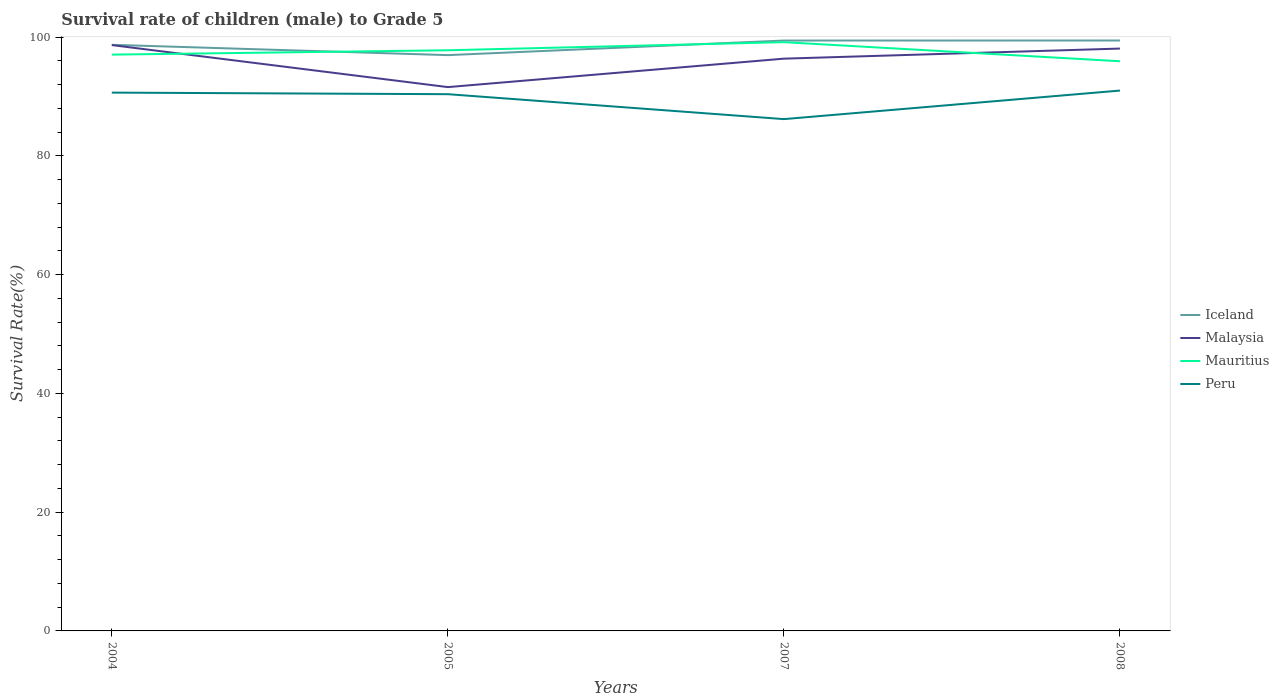How many different coloured lines are there?
Offer a very short reply. 4. Does the line corresponding to Peru intersect with the line corresponding to Mauritius?
Provide a succinct answer. No. Is the number of lines equal to the number of legend labels?
Keep it short and to the point. Yes. Across all years, what is the maximum survival rate of male children to grade 5 in Malaysia?
Your answer should be very brief. 91.58. In which year was the survival rate of male children to grade 5 in Mauritius maximum?
Ensure brevity in your answer.  2008. What is the total survival rate of male children to grade 5 in Peru in the graph?
Ensure brevity in your answer.  4.2. What is the difference between the highest and the second highest survival rate of male children to grade 5 in Malaysia?
Keep it short and to the point. 7.08. What is the difference between the highest and the lowest survival rate of male children to grade 5 in Mauritius?
Provide a short and direct response. 2. Is the survival rate of male children to grade 5 in Mauritius strictly greater than the survival rate of male children to grade 5 in Peru over the years?
Give a very brief answer. No. How many years are there in the graph?
Offer a terse response. 4. What is the difference between two consecutive major ticks on the Y-axis?
Give a very brief answer. 20. Are the values on the major ticks of Y-axis written in scientific E-notation?
Your answer should be very brief. No. Where does the legend appear in the graph?
Provide a short and direct response. Center right. How many legend labels are there?
Give a very brief answer. 4. What is the title of the graph?
Keep it short and to the point. Survival rate of children (male) to Grade 5. Does "Sri Lanka" appear as one of the legend labels in the graph?
Your response must be concise. No. What is the label or title of the Y-axis?
Your response must be concise. Survival Rate(%). What is the Survival Rate(%) of Iceland in 2004?
Offer a very short reply. 98.7. What is the Survival Rate(%) of Malaysia in 2004?
Ensure brevity in your answer.  98.66. What is the Survival Rate(%) of Mauritius in 2004?
Keep it short and to the point. 97.05. What is the Survival Rate(%) of Peru in 2004?
Provide a succinct answer. 90.65. What is the Survival Rate(%) of Iceland in 2005?
Ensure brevity in your answer.  96.97. What is the Survival Rate(%) in Malaysia in 2005?
Give a very brief answer. 91.58. What is the Survival Rate(%) of Mauritius in 2005?
Provide a succinct answer. 97.78. What is the Survival Rate(%) of Peru in 2005?
Your response must be concise. 90.39. What is the Survival Rate(%) in Iceland in 2007?
Your response must be concise. 99.42. What is the Survival Rate(%) of Malaysia in 2007?
Give a very brief answer. 96.37. What is the Survival Rate(%) in Mauritius in 2007?
Offer a very short reply. 99.15. What is the Survival Rate(%) in Peru in 2007?
Make the answer very short. 86.19. What is the Survival Rate(%) of Iceland in 2008?
Offer a very short reply. 99.43. What is the Survival Rate(%) of Malaysia in 2008?
Offer a terse response. 98.07. What is the Survival Rate(%) of Mauritius in 2008?
Offer a very short reply. 95.94. What is the Survival Rate(%) of Peru in 2008?
Your answer should be very brief. 91. Across all years, what is the maximum Survival Rate(%) in Iceland?
Make the answer very short. 99.43. Across all years, what is the maximum Survival Rate(%) in Malaysia?
Your answer should be very brief. 98.66. Across all years, what is the maximum Survival Rate(%) of Mauritius?
Keep it short and to the point. 99.15. Across all years, what is the maximum Survival Rate(%) of Peru?
Offer a terse response. 91. Across all years, what is the minimum Survival Rate(%) of Iceland?
Make the answer very short. 96.97. Across all years, what is the minimum Survival Rate(%) of Malaysia?
Ensure brevity in your answer.  91.58. Across all years, what is the minimum Survival Rate(%) in Mauritius?
Keep it short and to the point. 95.94. Across all years, what is the minimum Survival Rate(%) in Peru?
Keep it short and to the point. 86.19. What is the total Survival Rate(%) in Iceland in the graph?
Keep it short and to the point. 394.52. What is the total Survival Rate(%) of Malaysia in the graph?
Your answer should be compact. 384.68. What is the total Survival Rate(%) of Mauritius in the graph?
Give a very brief answer. 389.92. What is the total Survival Rate(%) in Peru in the graph?
Your answer should be compact. 358.23. What is the difference between the Survival Rate(%) of Iceland in 2004 and that in 2005?
Offer a terse response. 1.73. What is the difference between the Survival Rate(%) of Malaysia in 2004 and that in 2005?
Make the answer very short. 7.08. What is the difference between the Survival Rate(%) in Mauritius in 2004 and that in 2005?
Provide a short and direct response. -0.73. What is the difference between the Survival Rate(%) of Peru in 2004 and that in 2005?
Make the answer very short. 0.26. What is the difference between the Survival Rate(%) in Iceland in 2004 and that in 2007?
Offer a terse response. -0.72. What is the difference between the Survival Rate(%) in Malaysia in 2004 and that in 2007?
Make the answer very short. 2.29. What is the difference between the Survival Rate(%) in Mauritius in 2004 and that in 2007?
Your answer should be compact. -2.1. What is the difference between the Survival Rate(%) of Peru in 2004 and that in 2007?
Your answer should be very brief. 4.46. What is the difference between the Survival Rate(%) in Iceland in 2004 and that in 2008?
Provide a short and direct response. -0.73. What is the difference between the Survival Rate(%) of Malaysia in 2004 and that in 2008?
Your answer should be very brief. 0.59. What is the difference between the Survival Rate(%) in Mauritius in 2004 and that in 2008?
Offer a terse response. 1.11. What is the difference between the Survival Rate(%) in Peru in 2004 and that in 2008?
Your answer should be compact. -0.34. What is the difference between the Survival Rate(%) of Iceland in 2005 and that in 2007?
Your answer should be very brief. -2.45. What is the difference between the Survival Rate(%) of Malaysia in 2005 and that in 2007?
Provide a succinct answer. -4.79. What is the difference between the Survival Rate(%) in Mauritius in 2005 and that in 2007?
Provide a succinct answer. -1.37. What is the difference between the Survival Rate(%) of Peru in 2005 and that in 2007?
Your answer should be very brief. 4.2. What is the difference between the Survival Rate(%) in Iceland in 2005 and that in 2008?
Offer a terse response. -2.46. What is the difference between the Survival Rate(%) in Malaysia in 2005 and that in 2008?
Keep it short and to the point. -6.49. What is the difference between the Survival Rate(%) in Mauritius in 2005 and that in 2008?
Your answer should be very brief. 1.85. What is the difference between the Survival Rate(%) of Peru in 2005 and that in 2008?
Your answer should be compact. -0.61. What is the difference between the Survival Rate(%) of Iceland in 2007 and that in 2008?
Make the answer very short. -0.01. What is the difference between the Survival Rate(%) of Malaysia in 2007 and that in 2008?
Give a very brief answer. -1.7. What is the difference between the Survival Rate(%) of Mauritius in 2007 and that in 2008?
Your answer should be very brief. 3.22. What is the difference between the Survival Rate(%) of Peru in 2007 and that in 2008?
Offer a very short reply. -4.81. What is the difference between the Survival Rate(%) in Iceland in 2004 and the Survival Rate(%) in Malaysia in 2005?
Provide a succinct answer. 7.12. What is the difference between the Survival Rate(%) of Iceland in 2004 and the Survival Rate(%) of Mauritius in 2005?
Make the answer very short. 0.92. What is the difference between the Survival Rate(%) of Iceland in 2004 and the Survival Rate(%) of Peru in 2005?
Your response must be concise. 8.31. What is the difference between the Survival Rate(%) in Malaysia in 2004 and the Survival Rate(%) in Mauritius in 2005?
Make the answer very short. 0.87. What is the difference between the Survival Rate(%) in Malaysia in 2004 and the Survival Rate(%) in Peru in 2005?
Keep it short and to the point. 8.27. What is the difference between the Survival Rate(%) of Mauritius in 2004 and the Survival Rate(%) of Peru in 2005?
Make the answer very short. 6.66. What is the difference between the Survival Rate(%) in Iceland in 2004 and the Survival Rate(%) in Malaysia in 2007?
Your answer should be very brief. 2.33. What is the difference between the Survival Rate(%) of Iceland in 2004 and the Survival Rate(%) of Mauritius in 2007?
Offer a very short reply. -0.45. What is the difference between the Survival Rate(%) of Iceland in 2004 and the Survival Rate(%) of Peru in 2007?
Make the answer very short. 12.51. What is the difference between the Survival Rate(%) in Malaysia in 2004 and the Survival Rate(%) in Mauritius in 2007?
Provide a succinct answer. -0.49. What is the difference between the Survival Rate(%) of Malaysia in 2004 and the Survival Rate(%) of Peru in 2007?
Provide a short and direct response. 12.47. What is the difference between the Survival Rate(%) of Mauritius in 2004 and the Survival Rate(%) of Peru in 2007?
Your answer should be compact. 10.86. What is the difference between the Survival Rate(%) of Iceland in 2004 and the Survival Rate(%) of Malaysia in 2008?
Offer a very short reply. 0.63. What is the difference between the Survival Rate(%) in Iceland in 2004 and the Survival Rate(%) in Mauritius in 2008?
Your answer should be very brief. 2.77. What is the difference between the Survival Rate(%) of Iceland in 2004 and the Survival Rate(%) of Peru in 2008?
Keep it short and to the point. 7.7. What is the difference between the Survival Rate(%) of Malaysia in 2004 and the Survival Rate(%) of Mauritius in 2008?
Offer a terse response. 2.72. What is the difference between the Survival Rate(%) in Malaysia in 2004 and the Survival Rate(%) in Peru in 2008?
Offer a very short reply. 7.66. What is the difference between the Survival Rate(%) of Mauritius in 2004 and the Survival Rate(%) of Peru in 2008?
Your answer should be very brief. 6.05. What is the difference between the Survival Rate(%) of Iceland in 2005 and the Survival Rate(%) of Malaysia in 2007?
Provide a succinct answer. 0.6. What is the difference between the Survival Rate(%) of Iceland in 2005 and the Survival Rate(%) of Mauritius in 2007?
Your answer should be very brief. -2.18. What is the difference between the Survival Rate(%) in Iceland in 2005 and the Survival Rate(%) in Peru in 2007?
Offer a very short reply. 10.78. What is the difference between the Survival Rate(%) of Malaysia in 2005 and the Survival Rate(%) of Mauritius in 2007?
Provide a succinct answer. -7.57. What is the difference between the Survival Rate(%) in Malaysia in 2005 and the Survival Rate(%) in Peru in 2007?
Your answer should be very brief. 5.39. What is the difference between the Survival Rate(%) of Mauritius in 2005 and the Survival Rate(%) of Peru in 2007?
Give a very brief answer. 11.59. What is the difference between the Survival Rate(%) of Iceland in 2005 and the Survival Rate(%) of Malaysia in 2008?
Your response must be concise. -1.1. What is the difference between the Survival Rate(%) in Iceland in 2005 and the Survival Rate(%) in Mauritius in 2008?
Your answer should be very brief. 1.03. What is the difference between the Survival Rate(%) of Iceland in 2005 and the Survival Rate(%) of Peru in 2008?
Give a very brief answer. 5.97. What is the difference between the Survival Rate(%) of Malaysia in 2005 and the Survival Rate(%) of Mauritius in 2008?
Provide a succinct answer. -4.35. What is the difference between the Survival Rate(%) of Malaysia in 2005 and the Survival Rate(%) of Peru in 2008?
Offer a very short reply. 0.58. What is the difference between the Survival Rate(%) in Mauritius in 2005 and the Survival Rate(%) in Peru in 2008?
Ensure brevity in your answer.  6.79. What is the difference between the Survival Rate(%) in Iceland in 2007 and the Survival Rate(%) in Malaysia in 2008?
Keep it short and to the point. 1.35. What is the difference between the Survival Rate(%) in Iceland in 2007 and the Survival Rate(%) in Mauritius in 2008?
Give a very brief answer. 3.48. What is the difference between the Survival Rate(%) of Iceland in 2007 and the Survival Rate(%) of Peru in 2008?
Offer a terse response. 8.42. What is the difference between the Survival Rate(%) in Malaysia in 2007 and the Survival Rate(%) in Mauritius in 2008?
Offer a very short reply. 0.44. What is the difference between the Survival Rate(%) in Malaysia in 2007 and the Survival Rate(%) in Peru in 2008?
Offer a very short reply. 5.37. What is the difference between the Survival Rate(%) in Mauritius in 2007 and the Survival Rate(%) in Peru in 2008?
Provide a short and direct response. 8.15. What is the average Survival Rate(%) of Iceland per year?
Your answer should be compact. 98.63. What is the average Survival Rate(%) in Malaysia per year?
Ensure brevity in your answer.  96.17. What is the average Survival Rate(%) of Mauritius per year?
Make the answer very short. 97.48. What is the average Survival Rate(%) of Peru per year?
Ensure brevity in your answer.  89.56. In the year 2004, what is the difference between the Survival Rate(%) in Iceland and Survival Rate(%) in Malaysia?
Keep it short and to the point. 0.05. In the year 2004, what is the difference between the Survival Rate(%) in Iceland and Survival Rate(%) in Mauritius?
Your response must be concise. 1.65. In the year 2004, what is the difference between the Survival Rate(%) in Iceland and Survival Rate(%) in Peru?
Offer a terse response. 8.05. In the year 2004, what is the difference between the Survival Rate(%) of Malaysia and Survival Rate(%) of Mauritius?
Provide a succinct answer. 1.61. In the year 2004, what is the difference between the Survival Rate(%) in Malaysia and Survival Rate(%) in Peru?
Ensure brevity in your answer.  8. In the year 2004, what is the difference between the Survival Rate(%) in Mauritius and Survival Rate(%) in Peru?
Your response must be concise. 6.4. In the year 2005, what is the difference between the Survival Rate(%) of Iceland and Survival Rate(%) of Malaysia?
Provide a succinct answer. 5.39. In the year 2005, what is the difference between the Survival Rate(%) of Iceland and Survival Rate(%) of Mauritius?
Your answer should be very brief. -0.82. In the year 2005, what is the difference between the Survival Rate(%) of Iceland and Survival Rate(%) of Peru?
Provide a succinct answer. 6.58. In the year 2005, what is the difference between the Survival Rate(%) in Malaysia and Survival Rate(%) in Mauritius?
Provide a succinct answer. -6.2. In the year 2005, what is the difference between the Survival Rate(%) of Malaysia and Survival Rate(%) of Peru?
Keep it short and to the point. 1.19. In the year 2005, what is the difference between the Survival Rate(%) in Mauritius and Survival Rate(%) in Peru?
Ensure brevity in your answer.  7.39. In the year 2007, what is the difference between the Survival Rate(%) of Iceland and Survival Rate(%) of Malaysia?
Your response must be concise. 3.05. In the year 2007, what is the difference between the Survival Rate(%) in Iceland and Survival Rate(%) in Mauritius?
Keep it short and to the point. 0.27. In the year 2007, what is the difference between the Survival Rate(%) of Iceland and Survival Rate(%) of Peru?
Offer a very short reply. 13.23. In the year 2007, what is the difference between the Survival Rate(%) in Malaysia and Survival Rate(%) in Mauritius?
Provide a succinct answer. -2.78. In the year 2007, what is the difference between the Survival Rate(%) in Malaysia and Survival Rate(%) in Peru?
Keep it short and to the point. 10.18. In the year 2007, what is the difference between the Survival Rate(%) of Mauritius and Survival Rate(%) of Peru?
Give a very brief answer. 12.96. In the year 2008, what is the difference between the Survival Rate(%) in Iceland and Survival Rate(%) in Malaysia?
Make the answer very short. 1.36. In the year 2008, what is the difference between the Survival Rate(%) of Iceland and Survival Rate(%) of Mauritius?
Your answer should be compact. 3.49. In the year 2008, what is the difference between the Survival Rate(%) in Iceland and Survival Rate(%) in Peru?
Your answer should be very brief. 8.43. In the year 2008, what is the difference between the Survival Rate(%) of Malaysia and Survival Rate(%) of Mauritius?
Your answer should be very brief. 2.14. In the year 2008, what is the difference between the Survival Rate(%) in Malaysia and Survival Rate(%) in Peru?
Ensure brevity in your answer.  7.07. In the year 2008, what is the difference between the Survival Rate(%) of Mauritius and Survival Rate(%) of Peru?
Your answer should be very brief. 4.94. What is the ratio of the Survival Rate(%) in Iceland in 2004 to that in 2005?
Your answer should be compact. 1.02. What is the ratio of the Survival Rate(%) of Malaysia in 2004 to that in 2005?
Your response must be concise. 1.08. What is the ratio of the Survival Rate(%) in Malaysia in 2004 to that in 2007?
Keep it short and to the point. 1.02. What is the ratio of the Survival Rate(%) in Mauritius in 2004 to that in 2007?
Your response must be concise. 0.98. What is the ratio of the Survival Rate(%) of Peru in 2004 to that in 2007?
Provide a succinct answer. 1.05. What is the ratio of the Survival Rate(%) of Malaysia in 2004 to that in 2008?
Give a very brief answer. 1.01. What is the ratio of the Survival Rate(%) of Mauritius in 2004 to that in 2008?
Your answer should be very brief. 1.01. What is the ratio of the Survival Rate(%) in Peru in 2004 to that in 2008?
Make the answer very short. 1. What is the ratio of the Survival Rate(%) of Iceland in 2005 to that in 2007?
Your answer should be very brief. 0.98. What is the ratio of the Survival Rate(%) in Malaysia in 2005 to that in 2007?
Ensure brevity in your answer.  0.95. What is the ratio of the Survival Rate(%) of Mauritius in 2005 to that in 2007?
Ensure brevity in your answer.  0.99. What is the ratio of the Survival Rate(%) in Peru in 2005 to that in 2007?
Offer a terse response. 1.05. What is the ratio of the Survival Rate(%) of Iceland in 2005 to that in 2008?
Give a very brief answer. 0.98. What is the ratio of the Survival Rate(%) in Malaysia in 2005 to that in 2008?
Your answer should be compact. 0.93. What is the ratio of the Survival Rate(%) of Mauritius in 2005 to that in 2008?
Make the answer very short. 1.02. What is the ratio of the Survival Rate(%) in Peru in 2005 to that in 2008?
Offer a very short reply. 0.99. What is the ratio of the Survival Rate(%) of Malaysia in 2007 to that in 2008?
Provide a succinct answer. 0.98. What is the ratio of the Survival Rate(%) in Mauritius in 2007 to that in 2008?
Make the answer very short. 1.03. What is the ratio of the Survival Rate(%) of Peru in 2007 to that in 2008?
Your answer should be very brief. 0.95. What is the difference between the highest and the second highest Survival Rate(%) of Iceland?
Your answer should be very brief. 0.01. What is the difference between the highest and the second highest Survival Rate(%) in Malaysia?
Your answer should be compact. 0.59. What is the difference between the highest and the second highest Survival Rate(%) in Mauritius?
Offer a very short reply. 1.37. What is the difference between the highest and the second highest Survival Rate(%) in Peru?
Ensure brevity in your answer.  0.34. What is the difference between the highest and the lowest Survival Rate(%) of Iceland?
Provide a short and direct response. 2.46. What is the difference between the highest and the lowest Survival Rate(%) of Malaysia?
Make the answer very short. 7.08. What is the difference between the highest and the lowest Survival Rate(%) in Mauritius?
Offer a terse response. 3.22. What is the difference between the highest and the lowest Survival Rate(%) of Peru?
Your answer should be very brief. 4.81. 